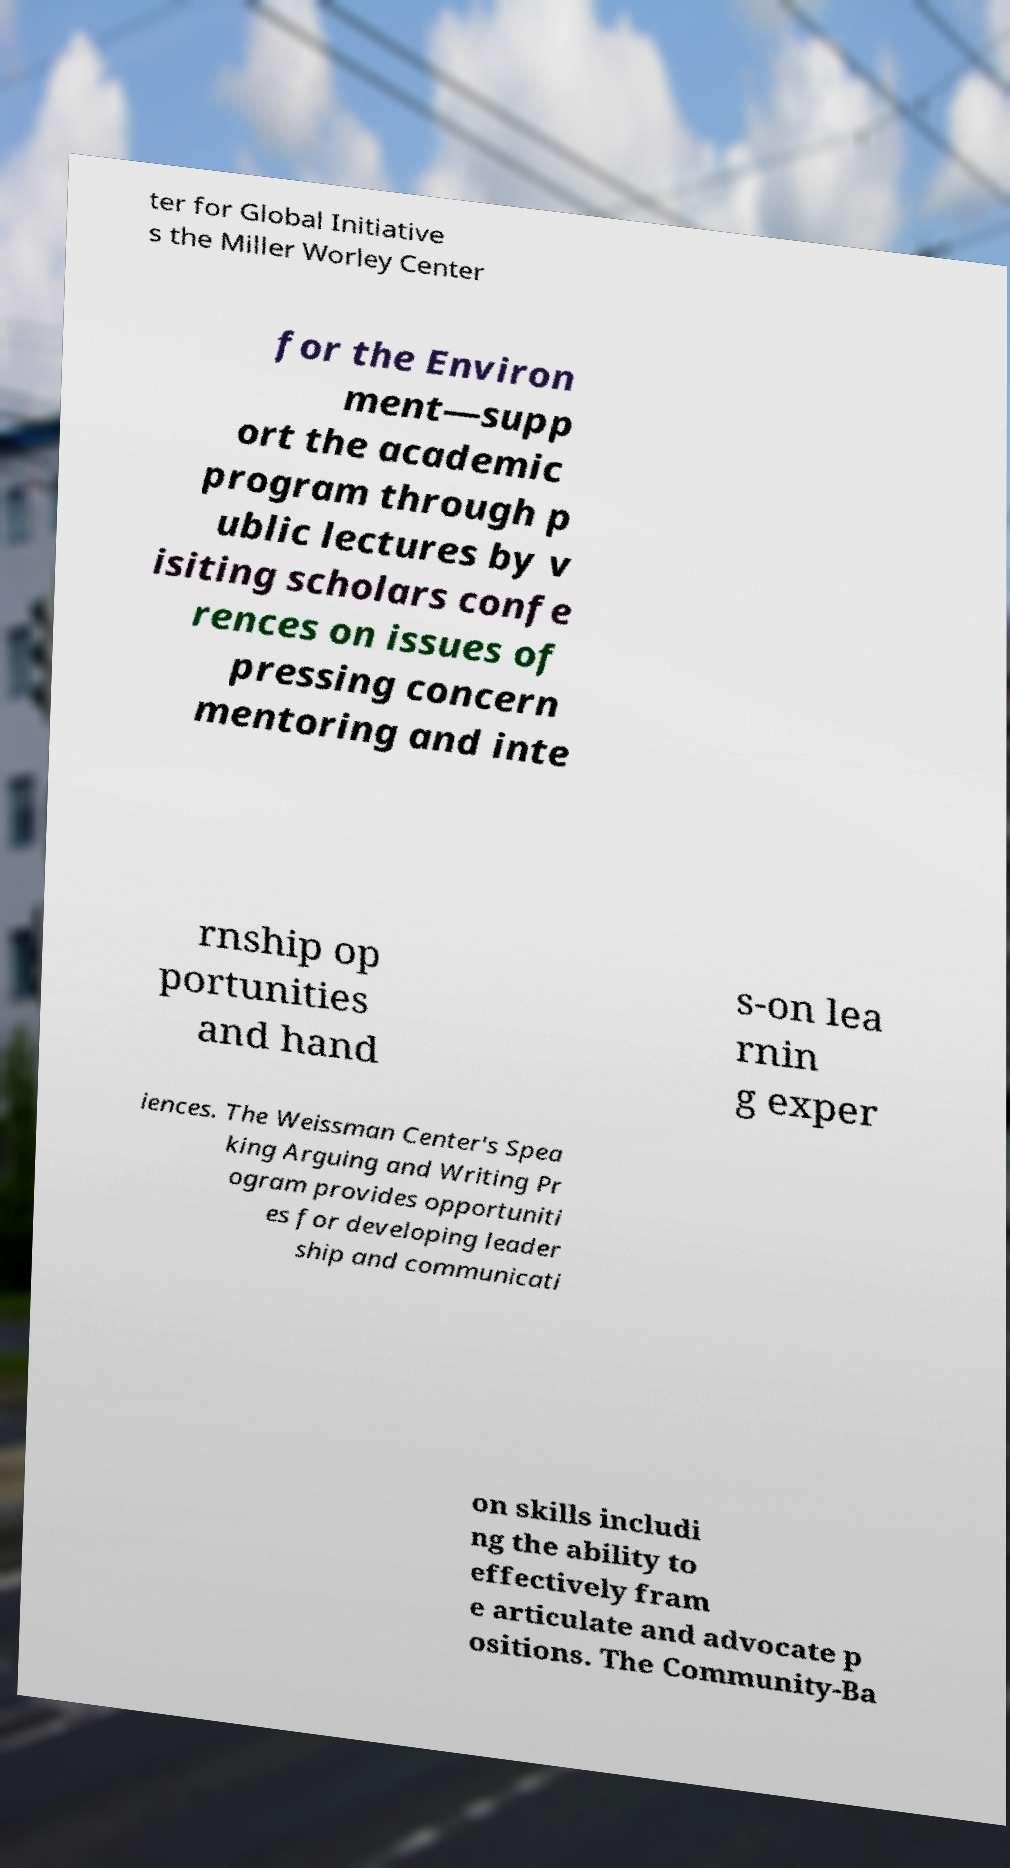There's text embedded in this image that I need extracted. Can you transcribe it verbatim? ter for Global Initiative s the Miller Worley Center for the Environ ment—supp ort the academic program through p ublic lectures by v isiting scholars confe rences on issues of pressing concern mentoring and inte rnship op portunities and hand s-on lea rnin g exper iences. The Weissman Center's Spea king Arguing and Writing Pr ogram provides opportuniti es for developing leader ship and communicati on skills includi ng the ability to effectively fram e articulate and advocate p ositions. The Community-Ba 